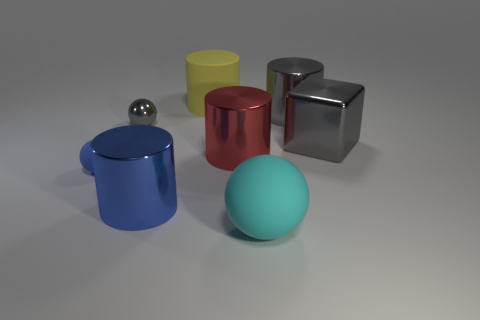Is the shape of the gray object that is left of the large cyan rubber ball the same as the large gray thing that is to the left of the big block?
Keep it short and to the point. No. What material is the cyan thing that is the same size as the yellow matte cylinder?
Your answer should be compact. Rubber. What number of other things are there of the same material as the large red object
Ensure brevity in your answer.  4. What is the shape of the big gray metallic thing on the left side of the large metal thing that is to the right of the large gray cylinder?
Offer a very short reply. Cylinder. What number of things are either tiny yellow rubber cubes or large cyan rubber spheres to the right of the gray sphere?
Give a very brief answer. 1. How many other objects are the same color as the large matte cylinder?
Your answer should be compact. 0. What number of red objects are small matte balls or spheres?
Your answer should be very brief. 0. Are there any big gray metal cylinders that are in front of the matte thing right of the red cylinder behind the cyan thing?
Provide a succinct answer. No. Are there any other things that have the same size as the matte cylinder?
Provide a succinct answer. Yes. Is the big cube the same color as the large rubber sphere?
Make the answer very short. No. 